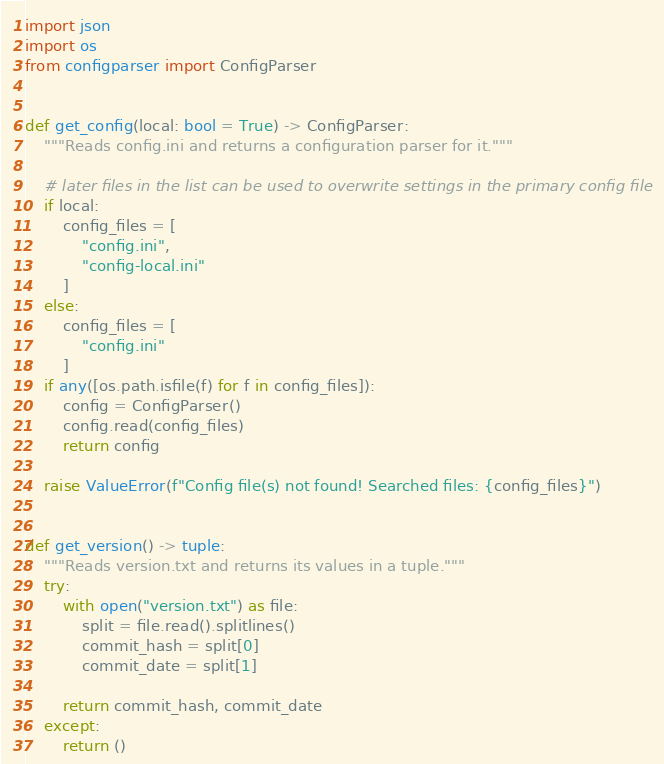<code> <loc_0><loc_0><loc_500><loc_500><_Python_>import json
import os
from configparser import ConfigParser


def get_config(local: bool = True) -> ConfigParser:
    """Reads config.ini and returns a configuration parser for it."""

    # later files in the list can be used to overwrite settings in the primary config file
    if local:
        config_files = [
            "config.ini",
            "config-local.ini"
        ]
    else:
        config_files = [
            "config.ini"
        ]
    if any([os.path.isfile(f) for f in config_files]):
        config = ConfigParser()
        config.read(config_files)
        return config

    raise ValueError(f"Config file(s) not found! Searched files: {config_files}")


def get_version() -> tuple:
    """Reads version.txt and returns its values in a tuple."""
    try:
        with open("version.txt") as file:
            split = file.read().splitlines()
            commit_hash = split[0]
            commit_date = split[1]

        return commit_hash, commit_date
    except:
        return ()
</code> 